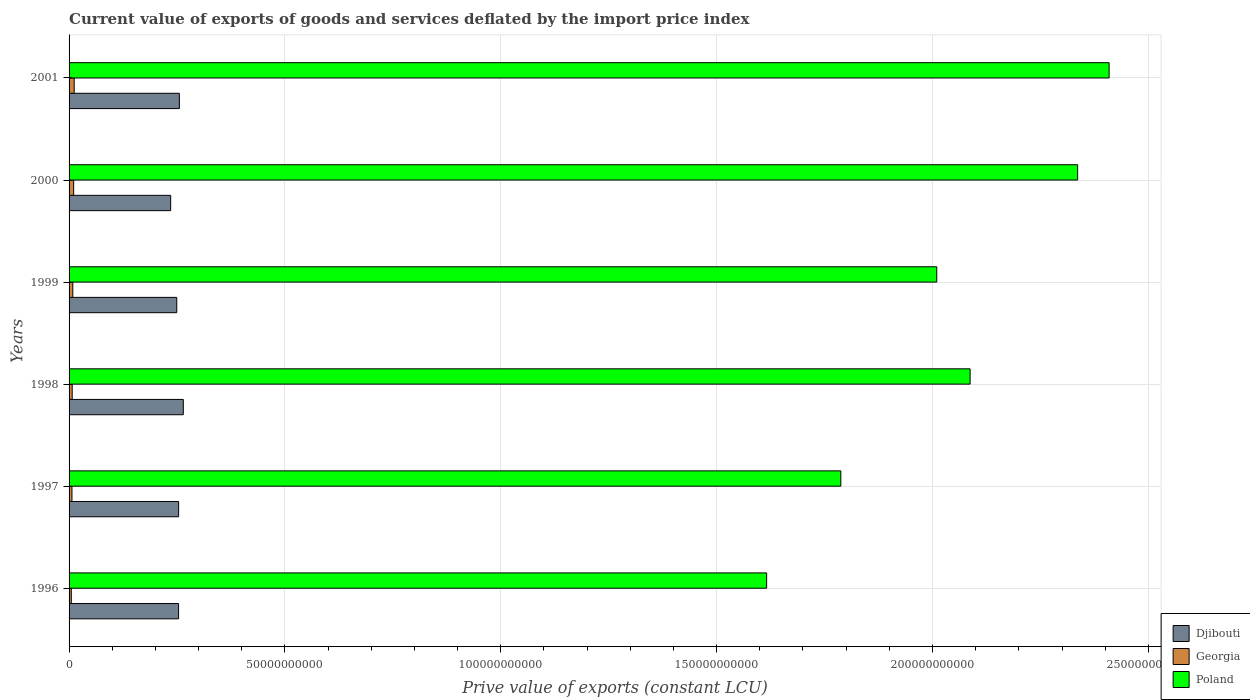How many different coloured bars are there?
Make the answer very short. 3. How many groups of bars are there?
Your answer should be compact. 6. Are the number of bars per tick equal to the number of legend labels?
Ensure brevity in your answer.  Yes. Are the number of bars on each tick of the Y-axis equal?
Offer a very short reply. Yes. What is the prive value of exports in Poland in 1996?
Offer a terse response. 1.62e+11. Across all years, what is the maximum prive value of exports in Georgia?
Your answer should be very brief. 1.18e+09. Across all years, what is the minimum prive value of exports in Poland?
Provide a succinct answer. 1.62e+11. In which year was the prive value of exports in Georgia maximum?
Your response must be concise. 2001. In which year was the prive value of exports in Poland minimum?
Give a very brief answer. 1996. What is the total prive value of exports in Georgia in the graph?
Offer a terse response. 5.02e+09. What is the difference between the prive value of exports in Georgia in 1998 and that in 1999?
Ensure brevity in your answer.  -1.39e+08. What is the difference between the prive value of exports in Djibouti in 2000 and the prive value of exports in Georgia in 1998?
Give a very brief answer. 2.28e+1. What is the average prive value of exports in Djibouti per year?
Your answer should be very brief. 2.52e+1. In the year 1996, what is the difference between the prive value of exports in Poland and prive value of exports in Georgia?
Make the answer very short. 1.61e+11. What is the ratio of the prive value of exports in Djibouti in 1997 to that in 1999?
Your response must be concise. 1.02. Is the prive value of exports in Djibouti in 1998 less than that in 2000?
Ensure brevity in your answer.  No. Is the difference between the prive value of exports in Poland in 1996 and 2000 greater than the difference between the prive value of exports in Georgia in 1996 and 2000?
Give a very brief answer. No. What is the difference between the highest and the second highest prive value of exports in Djibouti?
Keep it short and to the point. 9.13e+08. What is the difference between the highest and the lowest prive value of exports in Georgia?
Keep it short and to the point. 6.68e+08. Is the sum of the prive value of exports in Poland in 1997 and 2000 greater than the maximum prive value of exports in Georgia across all years?
Make the answer very short. Yes. What does the 3rd bar from the top in 1999 represents?
Offer a very short reply. Djibouti. What does the 1st bar from the bottom in 1997 represents?
Offer a terse response. Djibouti. Is it the case that in every year, the sum of the prive value of exports in Poland and prive value of exports in Djibouti is greater than the prive value of exports in Georgia?
Your answer should be compact. Yes. How many bars are there?
Provide a short and direct response. 18. How many years are there in the graph?
Your response must be concise. 6. What is the difference between two consecutive major ticks on the X-axis?
Give a very brief answer. 5.00e+1. Does the graph contain any zero values?
Offer a terse response. No. Does the graph contain grids?
Ensure brevity in your answer.  Yes. What is the title of the graph?
Offer a very short reply. Current value of exports of goods and services deflated by the import price index. Does "Iran" appear as one of the legend labels in the graph?
Your response must be concise. No. What is the label or title of the X-axis?
Your answer should be compact. Prive value of exports (constant LCU). What is the Prive value of exports (constant LCU) of Djibouti in 1996?
Keep it short and to the point. 2.54e+1. What is the Prive value of exports (constant LCU) in Georgia in 1996?
Keep it short and to the point. 5.16e+08. What is the Prive value of exports (constant LCU) of Poland in 1996?
Offer a very short reply. 1.62e+11. What is the Prive value of exports (constant LCU) in Djibouti in 1997?
Your response must be concise. 2.54e+1. What is the Prive value of exports (constant LCU) of Georgia in 1997?
Keep it short and to the point. 6.67e+08. What is the Prive value of exports (constant LCU) of Poland in 1997?
Offer a terse response. 1.79e+11. What is the Prive value of exports (constant LCU) of Djibouti in 1998?
Offer a terse response. 2.65e+1. What is the Prive value of exports (constant LCU) of Georgia in 1998?
Keep it short and to the point. 7.26e+08. What is the Prive value of exports (constant LCU) in Poland in 1998?
Provide a succinct answer. 2.09e+11. What is the Prive value of exports (constant LCU) of Djibouti in 1999?
Offer a terse response. 2.49e+1. What is the Prive value of exports (constant LCU) of Georgia in 1999?
Your answer should be very brief. 8.64e+08. What is the Prive value of exports (constant LCU) in Poland in 1999?
Offer a terse response. 2.01e+11. What is the Prive value of exports (constant LCU) in Djibouti in 2000?
Provide a short and direct response. 2.35e+1. What is the Prive value of exports (constant LCU) of Georgia in 2000?
Offer a terse response. 1.06e+09. What is the Prive value of exports (constant LCU) in Poland in 2000?
Offer a very short reply. 2.34e+11. What is the Prive value of exports (constant LCU) of Djibouti in 2001?
Offer a terse response. 2.55e+1. What is the Prive value of exports (constant LCU) of Georgia in 2001?
Offer a very short reply. 1.18e+09. What is the Prive value of exports (constant LCU) of Poland in 2001?
Make the answer very short. 2.41e+11. Across all years, what is the maximum Prive value of exports (constant LCU) of Djibouti?
Keep it short and to the point. 2.65e+1. Across all years, what is the maximum Prive value of exports (constant LCU) in Georgia?
Keep it short and to the point. 1.18e+09. Across all years, what is the maximum Prive value of exports (constant LCU) of Poland?
Make the answer very short. 2.41e+11. Across all years, what is the minimum Prive value of exports (constant LCU) of Djibouti?
Provide a succinct answer. 2.35e+1. Across all years, what is the minimum Prive value of exports (constant LCU) of Georgia?
Your answer should be compact. 5.16e+08. Across all years, what is the minimum Prive value of exports (constant LCU) of Poland?
Your answer should be very brief. 1.62e+11. What is the total Prive value of exports (constant LCU) in Djibouti in the graph?
Keep it short and to the point. 1.51e+11. What is the total Prive value of exports (constant LCU) in Georgia in the graph?
Your answer should be compact. 5.02e+09. What is the total Prive value of exports (constant LCU) in Poland in the graph?
Give a very brief answer. 1.22e+12. What is the difference between the Prive value of exports (constant LCU) of Djibouti in 1996 and that in 1997?
Your answer should be very brief. -1.16e+07. What is the difference between the Prive value of exports (constant LCU) of Georgia in 1996 and that in 1997?
Give a very brief answer. -1.52e+08. What is the difference between the Prive value of exports (constant LCU) of Poland in 1996 and that in 1997?
Provide a succinct answer. -1.72e+1. What is the difference between the Prive value of exports (constant LCU) of Djibouti in 1996 and that in 1998?
Your response must be concise. -1.10e+09. What is the difference between the Prive value of exports (constant LCU) of Georgia in 1996 and that in 1998?
Provide a succinct answer. -2.10e+08. What is the difference between the Prive value of exports (constant LCU) in Poland in 1996 and that in 1998?
Give a very brief answer. -4.71e+1. What is the difference between the Prive value of exports (constant LCU) in Djibouti in 1996 and that in 1999?
Provide a succinct answer. 4.19e+08. What is the difference between the Prive value of exports (constant LCU) of Georgia in 1996 and that in 1999?
Provide a succinct answer. -3.49e+08. What is the difference between the Prive value of exports (constant LCU) of Poland in 1996 and that in 1999?
Keep it short and to the point. -3.94e+1. What is the difference between the Prive value of exports (constant LCU) in Djibouti in 1996 and that in 2000?
Offer a terse response. 1.83e+09. What is the difference between the Prive value of exports (constant LCU) in Georgia in 1996 and that in 2000?
Offer a terse response. -5.46e+08. What is the difference between the Prive value of exports (constant LCU) of Poland in 1996 and that in 2000?
Your answer should be compact. -7.20e+1. What is the difference between the Prive value of exports (constant LCU) in Djibouti in 1996 and that in 2001?
Keep it short and to the point. -1.84e+08. What is the difference between the Prive value of exports (constant LCU) in Georgia in 1996 and that in 2001?
Provide a short and direct response. -6.68e+08. What is the difference between the Prive value of exports (constant LCU) in Poland in 1996 and that in 2001?
Provide a short and direct response. -7.93e+1. What is the difference between the Prive value of exports (constant LCU) in Djibouti in 1997 and that in 1998?
Your answer should be compact. -1.09e+09. What is the difference between the Prive value of exports (constant LCU) in Georgia in 1997 and that in 1998?
Ensure brevity in your answer.  -5.81e+07. What is the difference between the Prive value of exports (constant LCU) in Poland in 1997 and that in 1998?
Give a very brief answer. -2.99e+1. What is the difference between the Prive value of exports (constant LCU) of Djibouti in 1997 and that in 1999?
Your answer should be compact. 4.30e+08. What is the difference between the Prive value of exports (constant LCU) in Georgia in 1997 and that in 1999?
Your response must be concise. -1.97e+08. What is the difference between the Prive value of exports (constant LCU) in Poland in 1997 and that in 1999?
Provide a succinct answer. -2.22e+1. What is the difference between the Prive value of exports (constant LCU) in Djibouti in 1997 and that in 2000?
Your answer should be compact. 1.84e+09. What is the difference between the Prive value of exports (constant LCU) of Georgia in 1997 and that in 2000?
Keep it short and to the point. -3.94e+08. What is the difference between the Prive value of exports (constant LCU) in Poland in 1997 and that in 2000?
Your answer should be very brief. -5.49e+1. What is the difference between the Prive value of exports (constant LCU) in Djibouti in 1997 and that in 2001?
Your answer should be compact. -1.72e+08. What is the difference between the Prive value of exports (constant LCU) of Georgia in 1997 and that in 2001?
Your answer should be compact. -5.17e+08. What is the difference between the Prive value of exports (constant LCU) in Poland in 1997 and that in 2001?
Offer a terse response. -6.21e+1. What is the difference between the Prive value of exports (constant LCU) of Djibouti in 1998 and that in 1999?
Your answer should be very brief. 1.52e+09. What is the difference between the Prive value of exports (constant LCU) in Georgia in 1998 and that in 1999?
Offer a very short reply. -1.39e+08. What is the difference between the Prive value of exports (constant LCU) in Poland in 1998 and that in 1999?
Provide a succinct answer. 7.73e+09. What is the difference between the Prive value of exports (constant LCU) in Djibouti in 1998 and that in 2000?
Ensure brevity in your answer.  2.93e+09. What is the difference between the Prive value of exports (constant LCU) in Georgia in 1998 and that in 2000?
Offer a very short reply. -3.36e+08. What is the difference between the Prive value of exports (constant LCU) in Poland in 1998 and that in 2000?
Make the answer very short. -2.49e+1. What is the difference between the Prive value of exports (constant LCU) in Djibouti in 1998 and that in 2001?
Make the answer very short. 9.13e+08. What is the difference between the Prive value of exports (constant LCU) in Georgia in 1998 and that in 2001?
Keep it short and to the point. -4.58e+08. What is the difference between the Prive value of exports (constant LCU) of Poland in 1998 and that in 2001?
Offer a terse response. -3.22e+1. What is the difference between the Prive value of exports (constant LCU) in Djibouti in 1999 and that in 2000?
Offer a very short reply. 1.41e+09. What is the difference between the Prive value of exports (constant LCU) in Georgia in 1999 and that in 2000?
Make the answer very short. -1.98e+08. What is the difference between the Prive value of exports (constant LCU) of Poland in 1999 and that in 2000?
Offer a very short reply. -3.26e+1. What is the difference between the Prive value of exports (constant LCU) in Djibouti in 1999 and that in 2001?
Your response must be concise. -6.03e+08. What is the difference between the Prive value of exports (constant LCU) in Georgia in 1999 and that in 2001?
Your answer should be compact. -3.20e+08. What is the difference between the Prive value of exports (constant LCU) of Poland in 1999 and that in 2001?
Your answer should be compact. -3.99e+1. What is the difference between the Prive value of exports (constant LCU) of Djibouti in 2000 and that in 2001?
Offer a terse response. -2.02e+09. What is the difference between the Prive value of exports (constant LCU) of Georgia in 2000 and that in 2001?
Keep it short and to the point. -1.22e+08. What is the difference between the Prive value of exports (constant LCU) of Poland in 2000 and that in 2001?
Provide a short and direct response. -7.29e+09. What is the difference between the Prive value of exports (constant LCU) in Djibouti in 1996 and the Prive value of exports (constant LCU) in Georgia in 1997?
Offer a very short reply. 2.47e+1. What is the difference between the Prive value of exports (constant LCU) of Djibouti in 1996 and the Prive value of exports (constant LCU) of Poland in 1997?
Provide a short and direct response. -1.53e+11. What is the difference between the Prive value of exports (constant LCU) in Georgia in 1996 and the Prive value of exports (constant LCU) in Poland in 1997?
Your answer should be compact. -1.78e+11. What is the difference between the Prive value of exports (constant LCU) of Djibouti in 1996 and the Prive value of exports (constant LCU) of Georgia in 1998?
Provide a short and direct response. 2.46e+1. What is the difference between the Prive value of exports (constant LCU) in Djibouti in 1996 and the Prive value of exports (constant LCU) in Poland in 1998?
Give a very brief answer. -1.83e+11. What is the difference between the Prive value of exports (constant LCU) in Georgia in 1996 and the Prive value of exports (constant LCU) in Poland in 1998?
Offer a very short reply. -2.08e+11. What is the difference between the Prive value of exports (constant LCU) in Djibouti in 1996 and the Prive value of exports (constant LCU) in Georgia in 1999?
Make the answer very short. 2.45e+1. What is the difference between the Prive value of exports (constant LCU) in Djibouti in 1996 and the Prive value of exports (constant LCU) in Poland in 1999?
Offer a terse response. -1.76e+11. What is the difference between the Prive value of exports (constant LCU) in Georgia in 1996 and the Prive value of exports (constant LCU) in Poland in 1999?
Provide a short and direct response. -2.00e+11. What is the difference between the Prive value of exports (constant LCU) of Djibouti in 1996 and the Prive value of exports (constant LCU) of Georgia in 2000?
Your answer should be very brief. 2.43e+1. What is the difference between the Prive value of exports (constant LCU) in Djibouti in 1996 and the Prive value of exports (constant LCU) in Poland in 2000?
Make the answer very short. -2.08e+11. What is the difference between the Prive value of exports (constant LCU) in Georgia in 1996 and the Prive value of exports (constant LCU) in Poland in 2000?
Make the answer very short. -2.33e+11. What is the difference between the Prive value of exports (constant LCU) of Djibouti in 1996 and the Prive value of exports (constant LCU) of Georgia in 2001?
Offer a terse response. 2.42e+1. What is the difference between the Prive value of exports (constant LCU) of Djibouti in 1996 and the Prive value of exports (constant LCU) of Poland in 2001?
Provide a short and direct response. -2.16e+11. What is the difference between the Prive value of exports (constant LCU) in Georgia in 1996 and the Prive value of exports (constant LCU) in Poland in 2001?
Offer a very short reply. -2.40e+11. What is the difference between the Prive value of exports (constant LCU) in Djibouti in 1997 and the Prive value of exports (constant LCU) in Georgia in 1998?
Your answer should be compact. 2.47e+1. What is the difference between the Prive value of exports (constant LCU) in Djibouti in 1997 and the Prive value of exports (constant LCU) in Poland in 1998?
Your answer should be compact. -1.83e+11. What is the difference between the Prive value of exports (constant LCU) in Georgia in 1997 and the Prive value of exports (constant LCU) in Poland in 1998?
Your answer should be compact. -2.08e+11. What is the difference between the Prive value of exports (constant LCU) in Djibouti in 1997 and the Prive value of exports (constant LCU) in Georgia in 1999?
Offer a terse response. 2.45e+1. What is the difference between the Prive value of exports (constant LCU) in Djibouti in 1997 and the Prive value of exports (constant LCU) in Poland in 1999?
Give a very brief answer. -1.76e+11. What is the difference between the Prive value of exports (constant LCU) in Georgia in 1997 and the Prive value of exports (constant LCU) in Poland in 1999?
Provide a succinct answer. -2.00e+11. What is the difference between the Prive value of exports (constant LCU) in Djibouti in 1997 and the Prive value of exports (constant LCU) in Georgia in 2000?
Give a very brief answer. 2.43e+1. What is the difference between the Prive value of exports (constant LCU) of Djibouti in 1997 and the Prive value of exports (constant LCU) of Poland in 2000?
Ensure brevity in your answer.  -2.08e+11. What is the difference between the Prive value of exports (constant LCU) in Georgia in 1997 and the Prive value of exports (constant LCU) in Poland in 2000?
Your answer should be compact. -2.33e+11. What is the difference between the Prive value of exports (constant LCU) in Djibouti in 1997 and the Prive value of exports (constant LCU) in Georgia in 2001?
Provide a succinct answer. 2.42e+1. What is the difference between the Prive value of exports (constant LCU) of Djibouti in 1997 and the Prive value of exports (constant LCU) of Poland in 2001?
Make the answer very short. -2.16e+11. What is the difference between the Prive value of exports (constant LCU) in Georgia in 1997 and the Prive value of exports (constant LCU) in Poland in 2001?
Your response must be concise. -2.40e+11. What is the difference between the Prive value of exports (constant LCU) in Djibouti in 1998 and the Prive value of exports (constant LCU) in Georgia in 1999?
Your answer should be compact. 2.56e+1. What is the difference between the Prive value of exports (constant LCU) of Djibouti in 1998 and the Prive value of exports (constant LCU) of Poland in 1999?
Your answer should be very brief. -1.75e+11. What is the difference between the Prive value of exports (constant LCU) of Georgia in 1998 and the Prive value of exports (constant LCU) of Poland in 1999?
Your response must be concise. -2.00e+11. What is the difference between the Prive value of exports (constant LCU) of Djibouti in 1998 and the Prive value of exports (constant LCU) of Georgia in 2000?
Provide a short and direct response. 2.54e+1. What is the difference between the Prive value of exports (constant LCU) in Djibouti in 1998 and the Prive value of exports (constant LCU) in Poland in 2000?
Provide a short and direct response. -2.07e+11. What is the difference between the Prive value of exports (constant LCU) of Georgia in 1998 and the Prive value of exports (constant LCU) of Poland in 2000?
Your answer should be very brief. -2.33e+11. What is the difference between the Prive value of exports (constant LCU) in Djibouti in 1998 and the Prive value of exports (constant LCU) in Georgia in 2001?
Your answer should be very brief. 2.53e+1. What is the difference between the Prive value of exports (constant LCU) of Djibouti in 1998 and the Prive value of exports (constant LCU) of Poland in 2001?
Ensure brevity in your answer.  -2.14e+11. What is the difference between the Prive value of exports (constant LCU) in Georgia in 1998 and the Prive value of exports (constant LCU) in Poland in 2001?
Provide a succinct answer. -2.40e+11. What is the difference between the Prive value of exports (constant LCU) of Djibouti in 1999 and the Prive value of exports (constant LCU) of Georgia in 2000?
Provide a succinct answer. 2.39e+1. What is the difference between the Prive value of exports (constant LCU) of Djibouti in 1999 and the Prive value of exports (constant LCU) of Poland in 2000?
Your answer should be compact. -2.09e+11. What is the difference between the Prive value of exports (constant LCU) of Georgia in 1999 and the Prive value of exports (constant LCU) of Poland in 2000?
Offer a terse response. -2.33e+11. What is the difference between the Prive value of exports (constant LCU) of Djibouti in 1999 and the Prive value of exports (constant LCU) of Georgia in 2001?
Offer a very short reply. 2.38e+1. What is the difference between the Prive value of exports (constant LCU) in Djibouti in 1999 and the Prive value of exports (constant LCU) in Poland in 2001?
Make the answer very short. -2.16e+11. What is the difference between the Prive value of exports (constant LCU) in Georgia in 1999 and the Prive value of exports (constant LCU) in Poland in 2001?
Keep it short and to the point. -2.40e+11. What is the difference between the Prive value of exports (constant LCU) of Djibouti in 2000 and the Prive value of exports (constant LCU) of Georgia in 2001?
Offer a very short reply. 2.23e+1. What is the difference between the Prive value of exports (constant LCU) in Djibouti in 2000 and the Prive value of exports (constant LCU) in Poland in 2001?
Your answer should be very brief. -2.17e+11. What is the difference between the Prive value of exports (constant LCU) of Georgia in 2000 and the Prive value of exports (constant LCU) of Poland in 2001?
Offer a terse response. -2.40e+11. What is the average Prive value of exports (constant LCU) of Djibouti per year?
Give a very brief answer. 2.52e+1. What is the average Prive value of exports (constant LCU) of Georgia per year?
Give a very brief answer. 8.36e+08. What is the average Prive value of exports (constant LCU) in Poland per year?
Give a very brief answer. 2.04e+11. In the year 1996, what is the difference between the Prive value of exports (constant LCU) in Djibouti and Prive value of exports (constant LCU) in Georgia?
Give a very brief answer. 2.48e+1. In the year 1996, what is the difference between the Prive value of exports (constant LCU) in Djibouti and Prive value of exports (constant LCU) in Poland?
Your answer should be compact. -1.36e+11. In the year 1996, what is the difference between the Prive value of exports (constant LCU) of Georgia and Prive value of exports (constant LCU) of Poland?
Your response must be concise. -1.61e+11. In the year 1997, what is the difference between the Prive value of exports (constant LCU) of Djibouti and Prive value of exports (constant LCU) of Georgia?
Make the answer very short. 2.47e+1. In the year 1997, what is the difference between the Prive value of exports (constant LCU) in Djibouti and Prive value of exports (constant LCU) in Poland?
Offer a very short reply. -1.53e+11. In the year 1997, what is the difference between the Prive value of exports (constant LCU) in Georgia and Prive value of exports (constant LCU) in Poland?
Your response must be concise. -1.78e+11. In the year 1998, what is the difference between the Prive value of exports (constant LCU) in Djibouti and Prive value of exports (constant LCU) in Georgia?
Offer a terse response. 2.57e+1. In the year 1998, what is the difference between the Prive value of exports (constant LCU) in Djibouti and Prive value of exports (constant LCU) in Poland?
Provide a short and direct response. -1.82e+11. In the year 1998, what is the difference between the Prive value of exports (constant LCU) in Georgia and Prive value of exports (constant LCU) in Poland?
Give a very brief answer. -2.08e+11. In the year 1999, what is the difference between the Prive value of exports (constant LCU) in Djibouti and Prive value of exports (constant LCU) in Georgia?
Provide a short and direct response. 2.41e+1. In the year 1999, what is the difference between the Prive value of exports (constant LCU) in Djibouti and Prive value of exports (constant LCU) in Poland?
Give a very brief answer. -1.76e+11. In the year 1999, what is the difference between the Prive value of exports (constant LCU) in Georgia and Prive value of exports (constant LCU) in Poland?
Make the answer very short. -2.00e+11. In the year 2000, what is the difference between the Prive value of exports (constant LCU) in Djibouti and Prive value of exports (constant LCU) in Georgia?
Offer a terse response. 2.25e+1. In the year 2000, what is the difference between the Prive value of exports (constant LCU) in Djibouti and Prive value of exports (constant LCU) in Poland?
Keep it short and to the point. -2.10e+11. In the year 2000, what is the difference between the Prive value of exports (constant LCU) in Georgia and Prive value of exports (constant LCU) in Poland?
Ensure brevity in your answer.  -2.33e+11. In the year 2001, what is the difference between the Prive value of exports (constant LCU) in Djibouti and Prive value of exports (constant LCU) in Georgia?
Keep it short and to the point. 2.44e+1. In the year 2001, what is the difference between the Prive value of exports (constant LCU) in Djibouti and Prive value of exports (constant LCU) in Poland?
Provide a succinct answer. -2.15e+11. In the year 2001, what is the difference between the Prive value of exports (constant LCU) of Georgia and Prive value of exports (constant LCU) of Poland?
Make the answer very short. -2.40e+11. What is the ratio of the Prive value of exports (constant LCU) of Djibouti in 1996 to that in 1997?
Ensure brevity in your answer.  1. What is the ratio of the Prive value of exports (constant LCU) of Georgia in 1996 to that in 1997?
Ensure brevity in your answer.  0.77. What is the ratio of the Prive value of exports (constant LCU) of Poland in 1996 to that in 1997?
Offer a terse response. 0.9. What is the ratio of the Prive value of exports (constant LCU) in Djibouti in 1996 to that in 1998?
Your answer should be compact. 0.96. What is the ratio of the Prive value of exports (constant LCU) in Georgia in 1996 to that in 1998?
Ensure brevity in your answer.  0.71. What is the ratio of the Prive value of exports (constant LCU) in Poland in 1996 to that in 1998?
Offer a very short reply. 0.77. What is the ratio of the Prive value of exports (constant LCU) in Djibouti in 1996 to that in 1999?
Ensure brevity in your answer.  1.02. What is the ratio of the Prive value of exports (constant LCU) of Georgia in 1996 to that in 1999?
Your answer should be very brief. 0.6. What is the ratio of the Prive value of exports (constant LCU) in Poland in 1996 to that in 1999?
Your answer should be compact. 0.8. What is the ratio of the Prive value of exports (constant LCU) of Djibouti in 1996 to that in 2000?
Give a very brief answer. 1.08. What is the ratio of the Prive value of exports (constant LCU) in Georgia in 1996 to that in 2000?
Offer a very short reply. 0.49. What is the ratio of the Prive value of exports (constant LCU) in Poland in 1996 to that in 2000?
Provide a short and direct response. 0.69. What is the ratio of the Prive value of exports (constant LCU) in Georgia in 1996 to that in 2001?
Keep it short and to the point. 0.44. What is the ratio of the Prive value of exports (constant LCU) of Poland in 1996 to that in 2001?
Offer a terse response. 0.67. What is the ratio of the Prive value of exports (constant LCU) in Djibouti in 1997 to that in 1998?
Offer a very short reply. 0.96. What is the ratio of the Prive value of exports (constant LCU) of Georgia in 1997 to that in 1998?
Offer a terse response. 0.92. What is the ratio of the Prive value of exports (constant LCU) in Poland in 1997 to that in 1998?
Your answer should be very brief. 0.86. What is the ratio of the Prive value of exports (constant LCU) of Djibouti in 1997 to that in 1999?
Your answer should be very brief. 1.02. What is the ratio of the Prive value of exports (constant LCU) in Georgia in 1997 to that in 1999?
Your answer should be compact. 0.77. What is the ratio of the Prive value of exports (constant LCU) of Poland in 1997 to that in 1999?
Provide a succinct answer. 0.89. What is the ratio of the Prive value of exports (constant LCU) in Djibouti in 1997 to that in 2000?
Offer a terse response. 1.08. What is the ratio of the Prive value of exports (constant LCU) in Georgia in 1997 to that in 2000?
Offer a terse response. 0.63. What is the ratio of the Prive value of exports (constant LCU) of Poland in 1997 to that in 2000?
Ensure brevity in your answer.  0.77. What is the ratio of the Prive value of exports (constant LCU) in Georgia in 1997 to that in 2001?
Give a very brief answer. 0.56. What is the ratio of the Prive value of exports (constant LCU) of Poland in 1997 to that in 2001?
Give a very brief answer. 0.74. What is the ratio of the Prive value of exports (constant LCU) of Djibouti in 1998 to that in 1999?
Provide a short and direct response. 1.06. What is the ratio of the Prive value of exports (constant LCU) in Georgia in 1998 to that in 1999?
Your response must be concise. 0.84. What is the ratio of the Prive value of exports (constant LCU) of Poland in 1998 to that in 1999?
Your answer should be compact. 1.04. What is the ratio of the Prive value of exports (constant LCU) in Djibouti in 1998 to that in 2000?
Offer a terse response. 1.12. What is the ratio of the Prive value of exports (constant LCU) of Georgia in 1998 to that in 2000?
Make the answer very short. 0.68. What is the ratio of the Prive value of exports (constant LCU) of Poland in 1998 to that in 2000?
Ensure brevity in your answer.  0.89. What is the ratio of the Prive value of exports (constant LCU) of Djibouti in 1998 to that in 2001?
Provide a short and direct response. 1.04. What is the ratio of the Prive value of exports (constant LCU) in Georgia in 1998 to that in 2001?
Ensure brevity in your answer.  0.61. What is the ratio of the Prive value of exports (constant LCU) of Poland in 1998 to that in 2001?
Ensure brevity in your answer.  0.87. What is the ratio of the Prive value of exports (constant LCU) of Djibouti in 1999 to that in 2000?
Your response must be concise. 1.06. What is the ratio of the Prive value of exports (constant LCU) in Georgia in 1999 to that in 2000?
Provide a succinct answer. 0.81. What is the ratio of the Prive value of exports (constant LCU) of Poland in 1999 to that in 2000?
Your answer should be very brief. 0.86. What is the ratio of the Prive value of exports (constant LCU) of Djibouti in 1999 to that in 2001?
Make the answer very short. 0.98. What is the ratio of the Prive value of exports (constant LCU) in Georgia in 1999 to that in 2001?
Offer a very short reply. 0.73. What is the ratio of the Prive value of exports (constant LCU) of Poland in 1999 to that in 2001?
Make the answer very short. 0.83. What is the ratio of the Prive value of exports (constant LCU) of Djibouti in 2000 to that in 2001?
Give a very brief answer. 0.92. What is the ratio of the Prive value of exports (constant LCU) in Georgia in 2000 to that in 2001?
Offer a terse response. 0.9. What is the ratio of the Prive value of exports (constant LCU) in Poland in 2000 to that in 2001?
Your answer should be very brief. 0.97. What is the difference between the highest and the second highest Prive value of exports (constant LCU) of Djibouti?
Offer a very short reply. 9.13e+08. What is the difference between the highest and the second highest Prive value of exports (constant LCU) in Georgia?
Make the answer very short. 1.22e+08. What is the difference between the highest and the second highest Prive value of exports (constant LCU) of Poland?
Offer a terse response. 7.29e+09. What is the difference between the highest and the lowest Prive value of exports (constant LCU) in Djibouti?
Your answer should be compact. 2.93e+09. What is the difference between the highest and the lowest Prive value of exports (constant LCU) in Georgia?
Ensure brevity in your answer.  6.68e+08. What is the difference between the highest and the lowest Prive value of exports (constant LCU) in Poland?
Provide a succinct answer. 7.93e+1. 